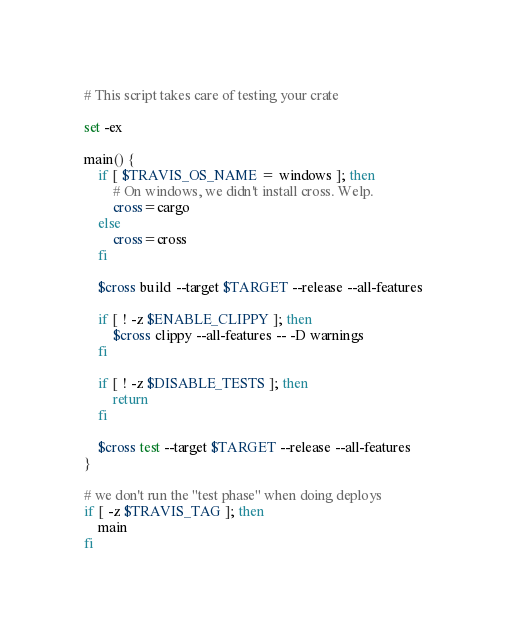<code> <loc_0><loc_0><loc_500><loc_500><_Bash_># This script takes care of testing your crate

set -ex

main() {
    if [ $TRAVIS_OS_NAME = windows ]; then
        # On windows, we didn't install cross. Welp.
        cross=cargo
    else
        cross=cross
    fi

    $cross build --target $TARGET --release --all-features

    if [ ! -z $ENABLE_CLIPPY ]; then
        $cross clippy --all-features -- -D warnings
    fi

    if [ ! -z $DISABLE_TESTS ]; then
        return
    fi

    $cross test --target $TARGET --release --all-features
}

# we don't run the "test phase" when doing deploys
if [ -z $TRAVIS_TAG ]; then
    main
fi
</code> 